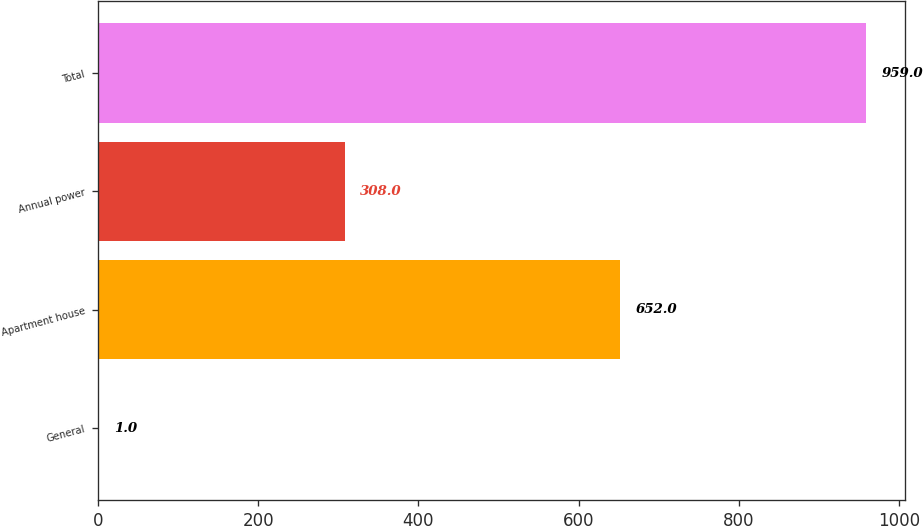<chart> <loc_0><loc_0><loc_500><loc_500><bar_chart><fcel>General<fcel>Apartment house<fcel>Annual power<fcel>Total<nl><fcel>1<fcel>652<fcel>308<fcel>959<nl></chart> 